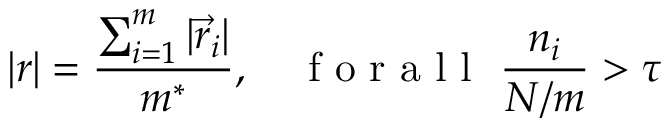Convert formula to latex. <formula><loc_0><loc_0><loc_500><loc_500>| r | = \frac { \sum _ { i = 1 } ^ { m } | \vec { r } _ { i } | } { m ^ { * } } , \quad f o r a l l \ \frac { n _ { i } } { N / m } > \tau</formula> 